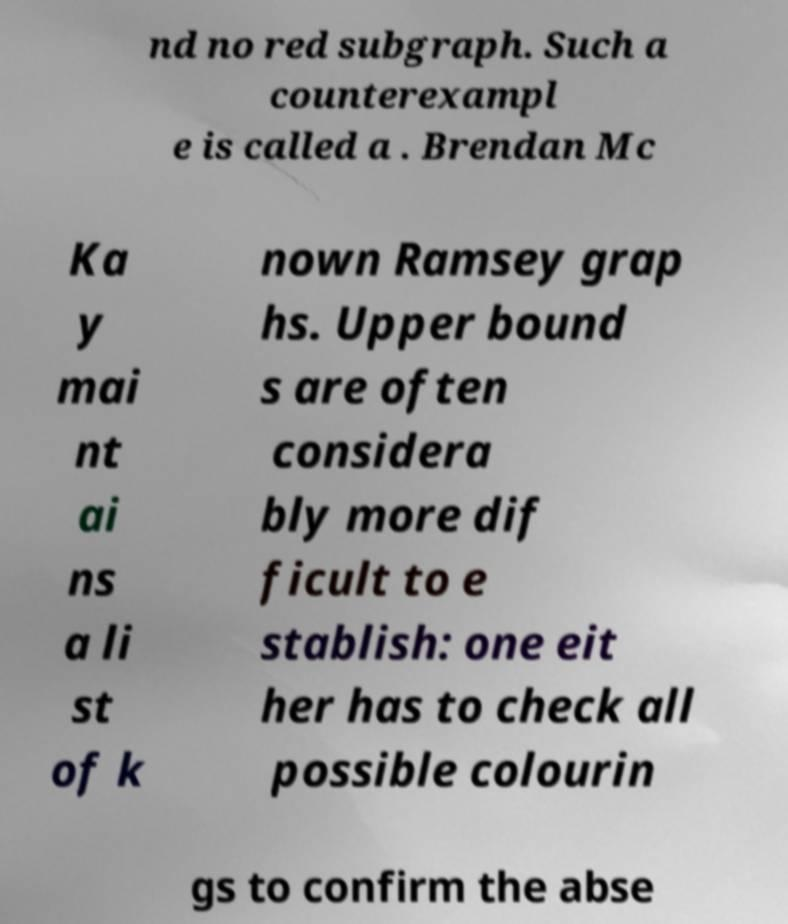What messages or text are displayed in this image? I need them in a readable, typed format. nd no red subgraph. Such a counterexampl e is called a . Brendan Mc Ka y mai nt ai ns a li st of k nown Ramsey grap hs. Upper bound s are often considera bly more dif ficult to e stablish: one eit her has to check all possible colourin gs to confirm the abse 